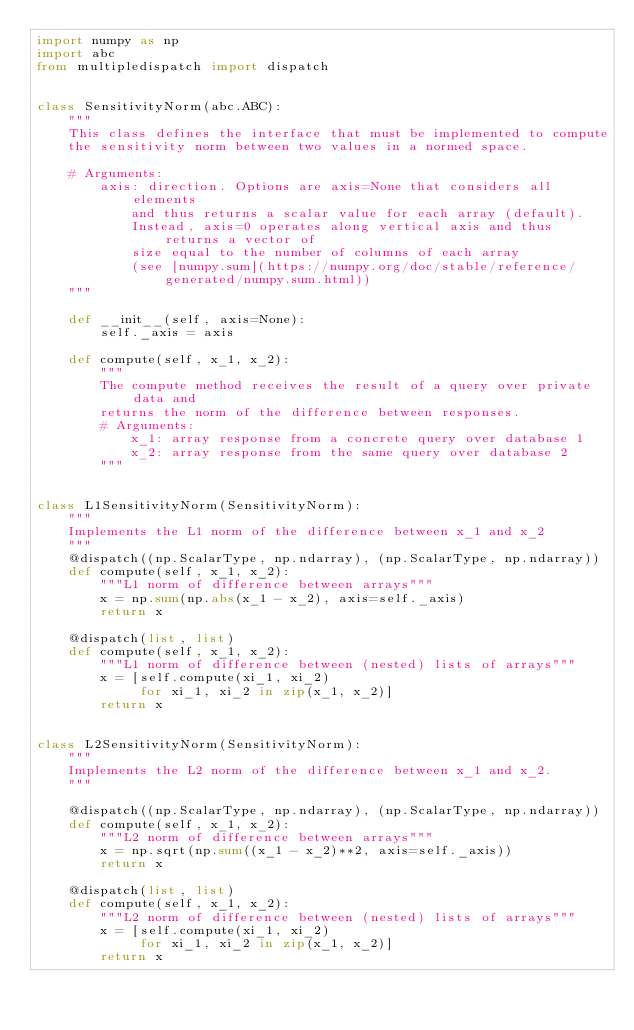Convert code to text. <code><loc_0><loc_0><loc_500><loc_500><_Python_>import numpy as np
import abc
from multipledispatch import dispatch


class SensitivityNorm(abc.ABC):
    """
    This class defines the interface that must be implemented to compute
    the sensitivity norm between two values in a normed space.

    # Arguments:
        axis: direction. Options are axis=None that considers all elements
            and thus returns a scalar value for each array (default).
            Instead, axis=0 operates along vertical axis and thus returns a vector of
            size equal to the number of columns of each array
            (see [numpy.sum](https://numpy.org/doc/stable/reference/generated/numpy.sum.html))
    """

    def __init__(self, axis=None):
        self._axis = axis

    def compute(self, x_1, x_2):
        """
        The compute method receives the result of a query over private data and
        returns the norm of the difference between responses.
        # Arguments:
            x_1: array response from a concrete query over database 1
            x_2: array response from the same query over database 2
        """


class L1SensitivityNorm(SensitivityNorm):
    """
    Implements the L1 norm of the difference between x_1 and x_2
    """
    @dispatch((np.ScalarType, np.ndarray), (np.ScalarType, np.ndarray))
    def compute(self, x_1, x_2):
        """L1 norm of difference between arrays"""
        x = np.sum(np.abs(x_1 - x_2), axis=self._axis)
        return x

    @dispatch(list, list)
    def compute(self, x_1, x_2):
        """L1 norm of difference between (nested) lists of arrays"""
        x = [self.compute(xi_1, xi_2)
             for xi_1, xi_2 in zip(x_1, x_2)]
        return x


class L2SensitivityNorm(SensitivityNorm):
    """
    Implements the L2 norm of the difference between x_1 and x_2.
    """

    @dispatch((np.ScalarType, np.ndarray), (np.ScalarType, np.ndarray))
    def compute(self, x_1, x_2):
        """L2 norm of difference between arrays"""
        x = np.sqrt(np.sum((x_1 - x_2)**2, axis=self._axis))
        return x

    @dispatch(list, list)
    def compute(self, x_1, x_2):
        """L2 norm of difference between (nested) lists of arrays"""
        x = [self.compute(xi_1, xi_2)
             for xi_1, xi_2 in zip(x_1, x_2)]
        return x
</code> 